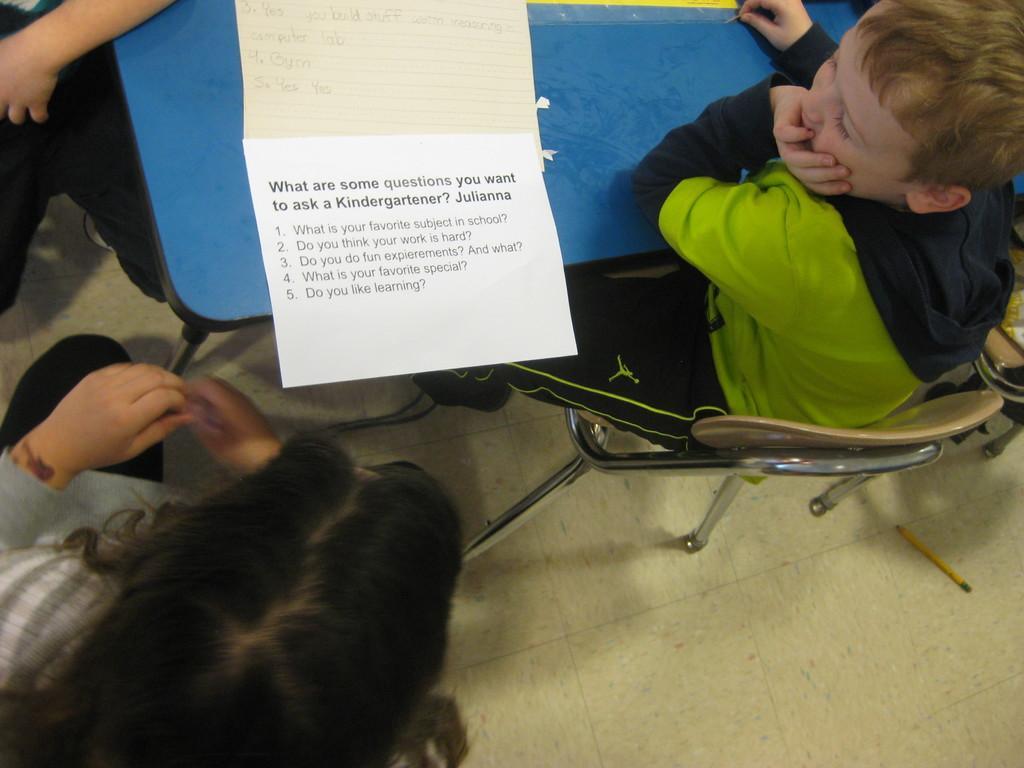How would you summarize this image in a sentence or two? In the picture we can see a boy sitting on the chair near the table keeping his hand on his mouth and beside him on the table we can see a paper with some questions on it and near to it we can see a girl is sitting on the chair and opposite side we can see a person hand on the table. 